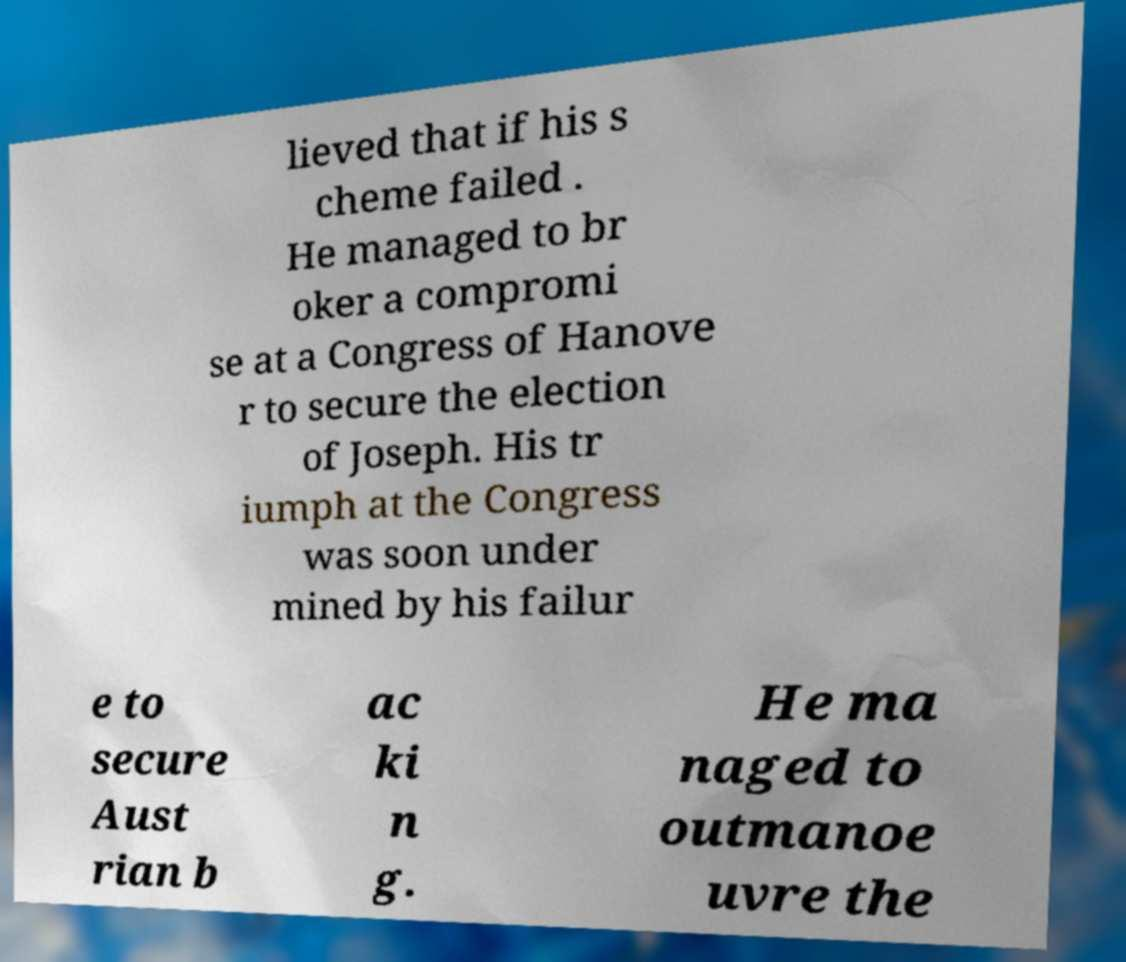Can you accurately transcribe the text from the provided image for me? lieved that if his s cheme failed . He managed to br oker a compromi se at a Congress of Hanove r to secure the election of Joseph. His tr iumph at the Congress was soon under mined by his failur e to secure Aust rian b ac ki n g. He ma naged to outmanoe uvre the 